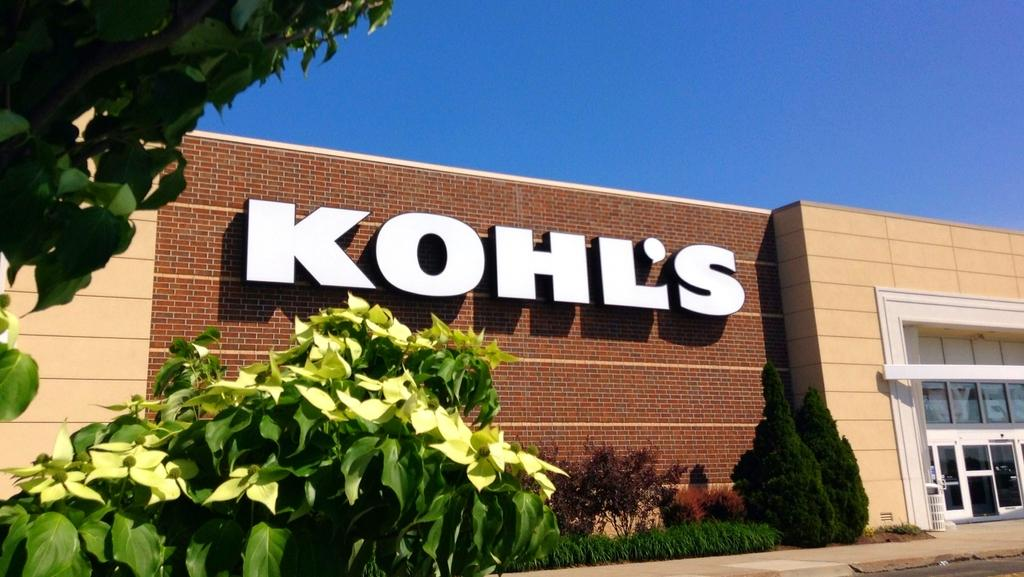What object made of brick can be seen in the image? There is a brick in the image. What type of structure is visible in the image? There is a house in the image. What type of doors are present in the house? There are glass doors in the image. What type of container is present in the image? There is a dustbin in the image. What type of vegetation is present in the image? There are plants and trees in the image. What type of path is present at the bottom of the image? There is a footpath at the bottom of the image. What is visible at the top of the image? The sky is visible at the top of the image. How many cats are playing with a match on the footpath in the image? There are no cats or matches present in the image. What type of snake can be seen slithering through the dustbin in the image? There are no snakes present in the image. 